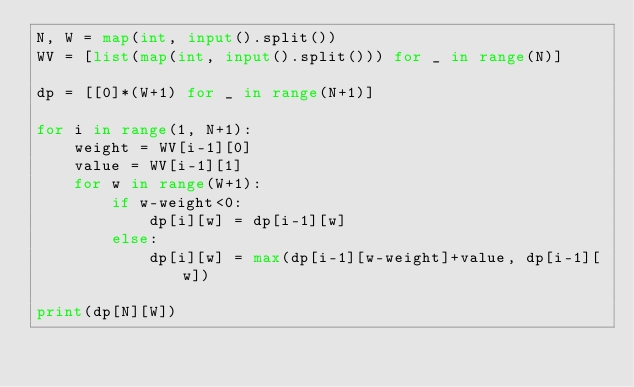<code> <loc_0><loc_0><loc_500><loc_500><_Python_>N, W = map(int, input().split())
WV = [list(map(int, input().split())) for _ in range(N)]

dp = [[0]*(W+1) for _ in range(N+1)]

for i in range(1, N+1):
    weight = WV[i-1][0]
    value = WV[i-1][1]
    for w in range(W+1):
        if w-weight<0:
            dp[i][w] = dp[i-1][w]
        else:
            dp[i][w] = max(dp[i-1][w-weight]+value, dp[i-1][w])

print(dp[N][W])
</code> 